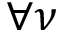<formula> <loc_0><loc_0><loc_500><loc_500>\forall \nu</formula> 